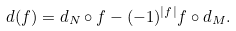Convert formula to latex. <formula><loc_0><loc_0><loc_500><loc_500>d ( f ) = d _ { N } \circ f - ( - 1 ) ^ { | f | } f \circ d _ { M } .</formula> 